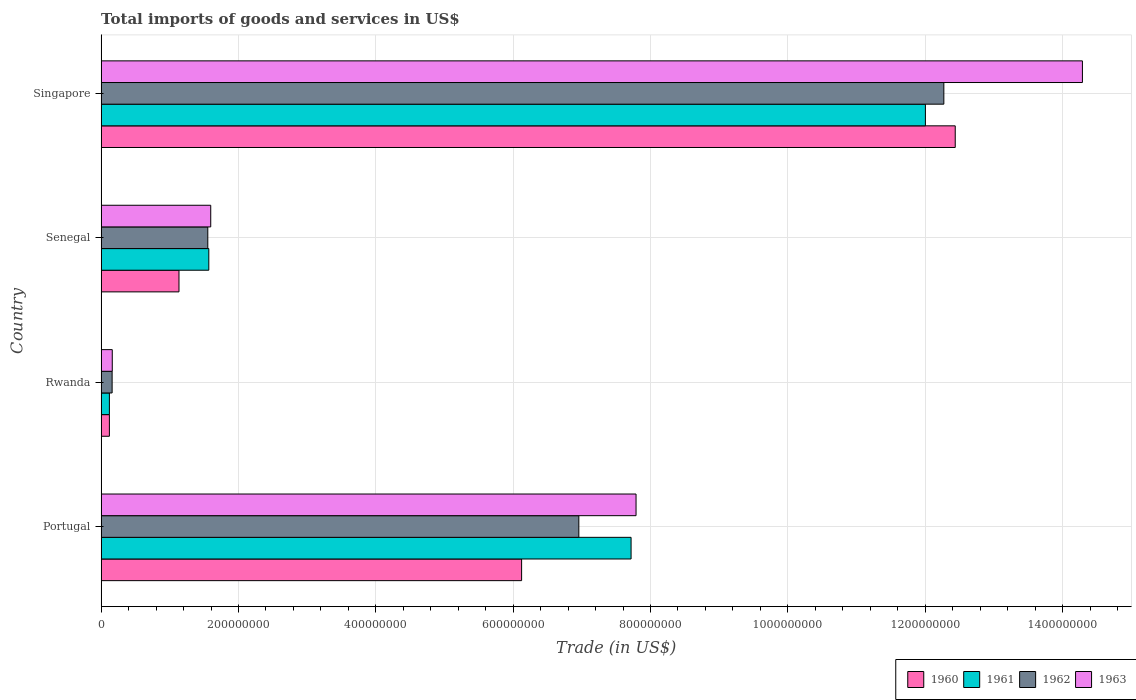How many groups of bars are there?
Your answer should be very brief. 4. How many bars are there on the 1st tick from the top?
Your answer should be compact. 4. How many bars are there on the 2nd tick from the bottom?
Make the answer very short. 4. What is the label of the 3rd group of bars from the top?
Your answer should be compact. Rwanda. In how many cases, is the number of bars for a given country not equal to the number of legend labels?
Your answer should be compact. 0. What is the total imports of goods and services in 1963 in Portugal?
Your answer should be very brief. 7.79e+08. Across all countries, what is the maximum total imports of goods and services in 1961?
Offer a terse response. 1.20e+09. Across all countries, what is the minimum total imports of goods and services in 1960?
Your answer should be very brief. 1.20e+07. In which country was the total imports of goods and services in 1961 maximum?
Provide a short and direct response. Singapore. In which country was the total imports of goods and services in 1961 minimum?
Offer a terse response. Rwanda. What is the total total imports of goods and services in 1961 in the graph?
Keep it short and to the point. 2.14e+09. What is the difference between the total imports of goods and services in 1962 in Portugal and that in Rwanda?
Make the answer very short. 6.80e+08. What is the difference between the total imports of goods and services in 1963 in Rwanda and the total imports of goods and services in 1961 in Senegal?
Make the answer very short. -1.41e+08. What is the average total imports of goods and services in 1961 per country?
Your answer should be compact. 5.35e+08. What is the difference between the total imports of goods and services in 1960 and total imports of goods and services in 1961 in Senegal?
Offer a very short reply. -4.35e+07. In how many countries, is the total imports of goods and services in 1960 greater than 360000000 US$?
Keep it short and to the point. 2. What is the ratio of the total imports of goods and services in 1961 in Portugal to that in Singapore?
Your answer should be compact. 0.64. Is the total imports of goods and services in 1961 in Portugal less than that in Senegal?
Ensure brevity in your answer.  No. What is the difference between the highest and the second highest total imports of goods and services in 1962?
Your response must be concise. 5.32e+08. What is the difference between the highest and the lowest total imports of goods and services in 1962?
Your answer should be very brief. 1.21e+09. In how many countries, is the total imports of goods and services in 1960 greater than the average total imports of goods and services in 1960 taken over all countries?
Your answer should be compact. 2. Is the sum of the total imports of goods and services in 1961 in Portugal and Senegal greater than the maximum total imports of goods and services in 1962 across all countries?
Your answer should be very brief. No. What does the 3rd bar from the top in Senegal represents?
Provide a short and direct response. 1961. What does the 2nd bar from the bottom in Singapore represents?
Offer a terse response. 1961. Where does the legend appear in the graph?
Make the answer very short. Bottom right. How many legend labels are there?
Ensure brevity in your answer.  4. What is the title of the graph?
Provide a short and direct response. Total imports of goods and services in US$. What is the label or title of the X-axis?
Your answer should be compact. Trade (in US$). What is the label or title of the Y-axis?
Give a very brief answer. Country. What is the Trade (in US$) of 1960 in Portugal?
Give a very brief answer. 6.12e+08. What is the Trade (in US$) of 1961 in Portugal?
Offer a terse response. 7.72e+08. What is the Trade (in US$) in 1962 in Portugal?
Ensure brevity in your answer.  6.96e+08. What is the Trade (in US$) in 1963 in Portugal?
Keep it short and to the point. 7.79e+08. What is the Trade (in US$) of 1960 in Rwanda?
Give a very brief answer. 1.20e+07. What is the Trade (in US$) in 1961 in Rwanda?
Offer a very short reply. 1.20e+07. What is the Trade (in US$) of 1962 in Rwanda?
Your answer should be compact. 1.60e+07. What is the Trade (in US$) of 1963 in Rwanda?
Offer a terse response. 1.62e+07. What is the Trade (in US$) of 1960 in Senegal?
Offer a very short reply. 1.13e+08. What is the Trade (in US$) in 1961 in Senegal?
Your answer should be compact. 1.57e+08. What is the Trade (in US$) of 1962 in Senegal?
Give a very brief answer. 1.55e+08. What is the Trade (in US$) of 1963 in Senegal?
Provide a short and direct response. 1.60e+08. What is the Trade (in US$) of 1960 in Singapore?
Give a very brief answer. 1.24e+09. What is the Trade (in US$) in 1961 in Singapore?
Offer a terse response. 1.20e+09. What is the Trade (in US$) in 1962 in Singapore?
Offer a terse response. 1.23e+09. What is the Trade (in US$) in 1963 in Singapore?
Make the answer very short. 1.43e+09. Across all countries, what is the maximum Trade (in US$) in 1960?
Offer a terse response. 1.24e+09. Across all countries, what is the maximum Trade (in US$) in 1961?
Give a very brief answer. 1.20e+09. Across all countries, what is the maximum Trade (in US$) in 1962?
Provide a short and direct response. 1.23e+09. Across all countries, what is the maximum Trade (in US$) of 1963?
Keep it short and to the point. 1.43e+09. Across all countries, what is the minimum Trade (in US$) of 1960?
Offer a very short reply. 1.20e+07. Across all countries, what is the minimum Trade (in US$) of 1961?
Ensure brevity in your answer.  1.20e+07. Across all countries, what is the minimum Trade (in US$) in 1962?
Ensure brevity in your answer.  1.60e+07. Across all countries, what is the minimum Trade (in US$) of 1963?
Ensure brevity in your answer.  1.62e+07. What is the total Trade (in US$) of 1960 in the graph?
Your response must be concise. 1.98e+09. What is the total Trade (in US$) in 1961 in the graph?
Your answer should be compact. 2.14e+09. What is the total Trade (in US$) in 1962 in the graph?
Provide a short and direct response. 2.09e+09. What is the total Trade (in US$) in 1963 in the graph?
Keep it short and to the point. 2.38e+09. What is the difference between the Trade (in US$) of 1960 in Portugal and that in Rwanda?
Give a very brief answer. 6.00e+08. What is the difference between the Trade (in US$) of 1961 in Portugal and that in Rwanda?
Ensure brevity in your answer.  7.60e+08. What is the difference between the Trade (in US$) in 1962 in Portugal and that in Rwanda?
Your response must be concise. 6.80e+08. What is the difference between the Trade (in US$) in 1963 in Portugal and that in Rwanda?
Give a very brief answer. 7.63e+08. What is the difference between the Trade (in US$) of 1960 in Portugal and that in Senegal?
Provide a succinct answer. 4.99e+08. What is the difference between the Trade (in US$) of 1961 in Portugal and that in Senegal?
Make the answer very short. 6.15e+08. What is the difference between the Trade (in US$) in 1962 in Portugal and that in Senegal?
Offer a very short reply. 5.40e+08. What is the difference between the Trade (in US$) in 1963 in Portugal and that in Senegal?
Your answer should be very brief. 6.19e+08. What is the difference between the Trade (in US$) of 1960 in Portugal and that in Singapore?
Offer a very short reply. -6.31e+08. What is the difference between the Trade (in US$) in 1961 in Portugal and that in Singapore?
Your answer should be compact. -4.29e+08. What is the difference between the Trade (in US$) of 1962 in Portugal and that in Singapore?
Keep it short and to the point. -5.32e+08. What is the difference between the Trade (in US$) of 1963 in Portugal and that in Singapore?
Provide a short and direct response. -6.50e+08. What is the difference between the Trade (in US$) in 1960 in Rwanda and that in Senegal?
Provide a succinct answer. -1.01e+08. What is the difference between the Trade (in US$) of 1961 in Rwanda and that in Senegal?
Offer a terse response. -1.45e+08. What is the difference between the Trade (in US$) of 1962 in Rwanda and that in Senegal?
Give a very brief answer. -1.39e+08. What is the difference between the Trade (in US$) of 1963 in Rwanda and that in Senegal?
Provide a succinct answer. -1.43e+08. What is the difference between the Trade (in US$) in 1960 in Rwanda and that in Singapore?
Give a very brief answer. -1.23e+09. What is the difference between the Trade (in US$) in 1961 in Rwanda and that in Singapore?
Offer a terse response. -1.19e+09. What is the difference between the Trade (in US$) in 1962 in Rwanda and that in Singapore?
Offer a very short reply. -1.21e+09. What is the difference between the Trade (in US$) in 1963 in Rwanda and that in Singapore?
Your answer should be very brief. -1.41e+09. What is the difference between the Trade (in US$) in 1960 in Senegal and that in Singapore?
Offer a very short reply. -1.13e+09. What is the difference between the Trade (in US$) in 1961 in Senegal and that in Singapore?
Offer a terse response. -1.04e+09. What is the difference between the Trade (in US$) of 1962 in Senegal and that in Singapore?
Give a very brief answer. -1.07e+09. What is the difference between the Trade (in US$) in 1963 in Senegal and that in Singapore?
Your response must be concise. -1.27e+09. What is the difference between the Trade (in US$) of 1960 in Portugal and the Trade (in US$) of 1961 in Rwanda?
Offer a very short reply. 6.00e+08. What is the difference between the Trade (in US$) of 1960 in Portugal and the Trade (in US$) of 1962 in Rwanda?
Provide a succinct answer. 5.96e+08. What is the difference between the Trade (in US$) of 1960 in Portugal and the Trade (in US$) of 1963 in Rwanda?
Your answer should be compact. 5.96e+08. What is the difference between the Trade (in US$) of 1961 in Portugal and the Trade (in US$) of 1962 in Rwanda?
Ensure brevity in your answer.  7.56e+08. What is the difference between the Trade (in US$) in 1961 in Portugal and the Trade (in US$) in 1963 in Rwanda?
Your answer should be very brief. 7.55e+08. What is the difference between the Trade (in US$) in 1962 in Portugal and the Trade (in US$) in 1963 in Rwanda?
Your answer should be compact. 6.79e+08. What is the difference between the Trade (in US$) in 1960 in Portugal and the Trade (in US$) in 1961 in Senegal?
Your response must be concise. 4.55e+08. What is the difference between the Trade (in US$) in 1960 in Portugal and the Trade (in US$) in 1962 in Senegal?
Make the answer very short. 4.57e+08. What is the difference between the Trade (in US$) of 1960 in Portugal and the Trade (in US$) of 1963 in Senegal?
Your answer should be very brief. 4.53e+08. What is the difference between the Trade (in US$) of 1961 in Portugal and the Trade (in US$) of 1962 in Senegal?
Provide a succinct answer. 6.16e+08. What is the difference between the Trade (in US$) of 1961 in Portugal and the Trade (in US$) of 1963 in Senegal?
Provide a short and direct response. 6.12e+08. What is the difference between the Trade (in US$) of 1962 in Portugal and the Trade (in US$) of 1963 in Senegal?
Provide a short and direct response. 5.36e+08. What is the difference between the Trade (in US$) in 1960 in Portugal and the Trade (in US$) in 1961 in Singapore?
Your answer should be compact. -5.88e+08. What is the difference between the Trade (in US$) in 1960 in Portugal and the Trade (in US$) in 1962 in Singapore?
Keep it short and to the point. -6.15e+08. What is the difference between the Trade (in US$) of 1960 in Portugal and the Trade (in US$) of 1963 in Singapore?
Your response must be concise. -8.17e+08. What is the difference between the Trade (in US$) of 1961 in Portugal and the Trade (in US$) of 1962 in Singapore?
Your answer should be compact. -4.55e+08. What is the difference between the Trade (in US$) of 1961 in Portugal and the Trade (in US$) of 1963 in Singapore?
Your answer should be compact. -6.57e+08. What is the difference between the Trade (in US$) in 1962 in Portugal and the Trade (in US$) in 1963 in Singapore?
Ensure brevity in your answer.  -7.33e+08. What is the difference between the Trade (in US$) in 1960 in Rwanda and the Trade (in US$) in 1961 in Senegal?
Offer a very short reply. -1.45e+08. What is the difference between the Trade (in US$) of 1960 in Rwanda and the Trade (in US$) of 1962 in Senegal?
Give a very brief answer. -1.43e+08. What is the difference between the Trade (in US$) in 1960 in Rwanda and the Trade (in US$) in 1963 in Senegal?
Your answer should be very brief. -1.48e+08. What is the difference between the Trade (in US$) in 1961 in Rwanda and the Trade (in US$) in 1962 in Senegal?
Offer a very short reply. -1.43e+08. What is the difference between the Trade (in US$) in 1961 in Rwanda and the Trade (in US$) in 1963 in Senegal?
Give a very brief answer. -1.48e+08. What is the difference between the Trade (in US$) in 1962 in Rwanda and the Trade (in US$) in 1963 in Senegal?
Offer a terse response. -1.44e+08. What is the difference between the Trade (in US$) of 1960 in Rwanda and the Trade (in US$) of 1961 in Singapore?
Keep it short and to the point. -1.19e+09. What is the difference between the Trade (in US$) in 1960 in Rwanda and the Trade (in US$) in 1962 in Singapore?
Offer a terse response. -1.22e+09. What is the difference between the Trade (in US$) in 1960 in Rwanda and the Trade (in US$) in 1963 in Singapore?
Ensure brevity in your answer.  -1.42e+09. What is the difference between the Trade (in US$) of 1961 in Rwanda and the Trade (in US$) of 1962 in Singapore?
Your response must be concise. -1.22e+09. What is the difference between the Trade (in US$) in 1961 in Rwanda and the Trade (in US$) in 1963 in Singapore?
Give a very brief answer. -1.42e+09. What is the difference between the Trade (in US$) in 1962 in Rwanda and the Trade (in US$) in 1963 in Singapore?
Offer a very short reply. -1.41e+09. What is the difference between the Trade (in US$) of 1960 in Senegal and the Trade (in US$) of 1961 in Singapore?
Keep it short and to the point. -1.09e+09. What is the difference between the Trade (in US$) in 1960 in Senegal and the Trade (in US$) in 1962 in Singapore?
Your answer should be compact. -1.11e+09. What is the difference between the Trade (in US$) of 1960 in Senegal and the Trade (in US$) of 1963 in Singapore?
Provide a short and direct response. -1.32e+09. What is the difference between the Trade (in US$) in 1961 in Senegal and the Trade (in US$) in 1962 in Singapore?
Offer a very short reply. -1.07e+09. What is the difference between the Trade (in US$) in 1961 in Senegal and the Trade (in US$) in 1963 in Singapore?
Your response must be concise. -1.27e+09. What is the difference between the Trade (in US$) of 1962 in Senegal and the Trade (in US$) of 1963 in Singapore?
Ensure brevity in your answer.  -1.27e+09. What is the average Trade (in US$) in 1960 per country?
Your answer should be very brief. 4.95e+08. What is the average Trade (in US$) of 1961 per country?
Your answer should be very brief. 5.35e+08. What is the average Trade (in US$) of 1962 per country?
Keep it short and to the point. 5.24e+08. What is the average Trade (in US$) in 1963 per country?
Ensure brevity in your answer.  5.96e+08. What is the difference between the Trade (in US$) of 1960 and Trade (in US$) of 1961 in Portugal?
Your answer should be very brief. -1.59e+08. What is the difference between the Trade (in US$) in 1960 and Trade (in US$) in 1962 in Portugal?
Offer a very short reply. -8.33e+07. What is the difference between the Trade (in US$) of 1960 and Trade (in US$) of 1963 in Portugal?
Offer a very short reply. -1.67e+08. What is the difference between the Trade (in US$) in 1961 and Trade (in US$) in 1962 in Portugal?
Make the answer very short. 7.61e+07. What is the difference between the Trade (in US$) in 1961 and Trade (in US$) in 1963 in Portugal?
Provide a succinct answer. -7.25e+06. What is the difference between the Trade (in US$) of 1962 and Trade (in US$) of 1963 in Portugal?
Your response must be concise. -8.33e+07. What is the difference between the Trade (in US$) in 1960 and Trade (in US$) in 1962 in Rwanda?
Make the answer very short. -4.00e+06. What is the difference between the Trade (in US$) in 1960 and Trade (in US$) in 1963 in Rwanda?
Your answer should be very brief. -4.20e+06. What is the difference between the Trade (in US$) in 1961 and Trade (in US$) in 1962 in Rwanda?
Your response must be concise. -4.00e+06. What is the difference between the Trade (in US$) in 1961 and Trade (in US$) in 1963 in Rwanda?
Keep it short and to the point. -4.20e+06. What is the difference between the Trade (in US$) in 1962 and Trade (in US$) in 1963 in Rwanda?
Ensure brevity in your answer.  -2.00e+05. What is the difference between the Trade (in US$) of 1960 and Trade (in US$) of 1961 in Senegal?
Offer a very short reply. -4.35e+07. What is the difference between the Trade (in US$) in 1960 and Trade (in US$) in 1962 in Senegal?
Offer a very short reply. -4.20e+07. What is the difference between the Trade (in US$) of 1960 and Trade (in US$) of 1963 in Senegal?
Your answer should be very brief. -4.62e+07. What is the difference between the Trade (in US$) in 1961 and Trade (in US$) in 1962 in Senegal?
Offer a very short reply. 1.49e+06. What is the difference between the Trade (in US$) in 1961 and Trade (in US$) in 1963 in Senegal?
Make the answer very short. -2.79e+06. What is the difference between the Trade (in US$) of 1962 and Trade (in US$) of 1963 in Senegal?
Keep it short and to the point. -4.29e+06. What is the difference between the Trade (in US$) of 1960 and Trade (in US$) of 1961 in Singapore?
Offer a terse response. 4.34e+07. What is the difference between the Trade (in US$) of 1960 and Trade (in US$) of 1962 in Singapore?
Offer a very short reply. 1.66e+07. What is the difference between the Trade (in US$) of 1960 and Trade (in US$) of 1963 in Singapore?
Your response must be concise. -1.85e+08. What is the difference between the Trade (in US$) of 1961 and Trade (in US$) of 1962 in Singapore?
Provide a succinct answer. -2.69e+07. What is the difference between the Trade (in US$) in 1961 and Trade (in US$) in 1963 in Singapore?
Ensure brevity in your answer.  -2.29e+08. What is the difference between the Trade (in US$) in 1962 and Trade (in US$) in 1963 in Singapore?
Offer a very short reply. -2.02e+08. What is the ratio of the Trade (in US$) of 1960 in Portugal to that in Rwanda?
Provide a succinct answer. 51.02. What is the ratio of the Trade (in US$) of 1961 in Portugal to that in Rwanda?
Provide a short and direct response. 64.31. What is the ratio of the Trade (in US$) of 1962 in Portugal to that in Rwanda?
Offer a terse response. 43.48. What is the ratio of the Trade (in US$) in 1963 in Portugal to that in Rwanda?
Keep it short and to the point. 48.08. What is the ratio of the Trade (in US$) of 1960 in Portugal to that in Senegal?
Keep it short and to the point. 5.4. What is the ratio of the Trade (in US$) in 1961 in Portugal to that in Senegal?
Provide a short and direct response. 4.92. What is the ratio of the Trade (in US$) of 1962 in Portugal to that in Senegal?
Ensure brevity in your answer.  4.48. What is the ratio of the Trade (in US$) of 1963 in Portugal to that in Senegal?
Your answer should be very brief. 4.88. What is the ratio of the Trade (in US$) in 1960 in Portugal to that in Singapore?
Ensure brevity in your answer.  0.49. What is the ratio of the Trade (in US$) in 1961 in Portugal to that in Singapore?
Give a very brief answer. 0.64. What is the ratio of the Trade (in US$) of 1962 in Portugal to that in Singapore?
Your answer should be very brief. 0.57. What is the ratio of the Trade (in US$) in 1963 in Portugal to that in Singapore?
Make the answer very short. 0.55. What is the ratio of the Trade (in US$) of 1960 in Rwanda to that in Senegal?
Your answer should be very brief. 0.11. What is the ratio of the Trade (in US$) of 1961 in Rwanda to that in Senegal?
Give a very brief answer. 0.08. What is the ratio of the Trade (in US$) of 1962 in Rwanda to that in Senegal?
Offer a very short reply. 0.1. What is the ratio of the Trade (in US$) in 1963 in Rwanda to that in Senegal?
Keep it short and to the point. 0.1. What is the ratio of the Trade (in US$) of 1960 in Rwanda to that in Singapore?
Provide a succinct answer. 0.01. What is the ratio of the Trade (in US$) of 1962 in Rwanda to that in Singapore?
Offer a very short reply. 0.01. What is the ratio of the Trade (in US$) of 1963 in Rwanda to that in Singapore?
Provide a succinct answer. 0.01. What is the ratio of the Trade (in US$) of 1960 in Senegal to that in Singapore?
Provide a succinct answer. 0.09. What is the ratio of the Trade (in US$) of 1961 in Senegal to that in Singapore?
Keep it short and to the point. 0.13. What is the ratio of the Trade (in US$) in 1962 in Senegal to that in Singapore?
Make the answer very short. 0.13. What is the ratio of the Trade (in US$) in 1963 in Senegal to that in Singapore?
Offer a terse response. 0.11. What is the difference between the highest and the second highest Trade (in US$) in 1960?
Keep it short and to the point. 6.31e+08. What is the difference between the highest and the second highest Trade (in US$) in 1961?
Your answer should be very brief. 4.29e+08. What is the difference between the highest and the second highest Trade (in US$) of 1962?
Give a very brief answer. 5.32e+08. What is the difference between the highest and the second highest Trade (in US$) in 1963?
Give a very brief answer. 6.50e+08. What is the difference between the highest and the lowest Trade (in US$) of 1960?
Keep it short and to the point. 1.23e+09. What is the difference between the highest and the lowest Trade (in US$) of 1961?
Offer a terse response. 1.19e+09. What is the difference between the highest and the lowest Trade (in US$) in 1962?
Your answer should be very brief. 1.21e+09. What is the difference between the highest and the lowest Trade (in US$) in 1963?
Offer a very short reply. 1.41e+09. 